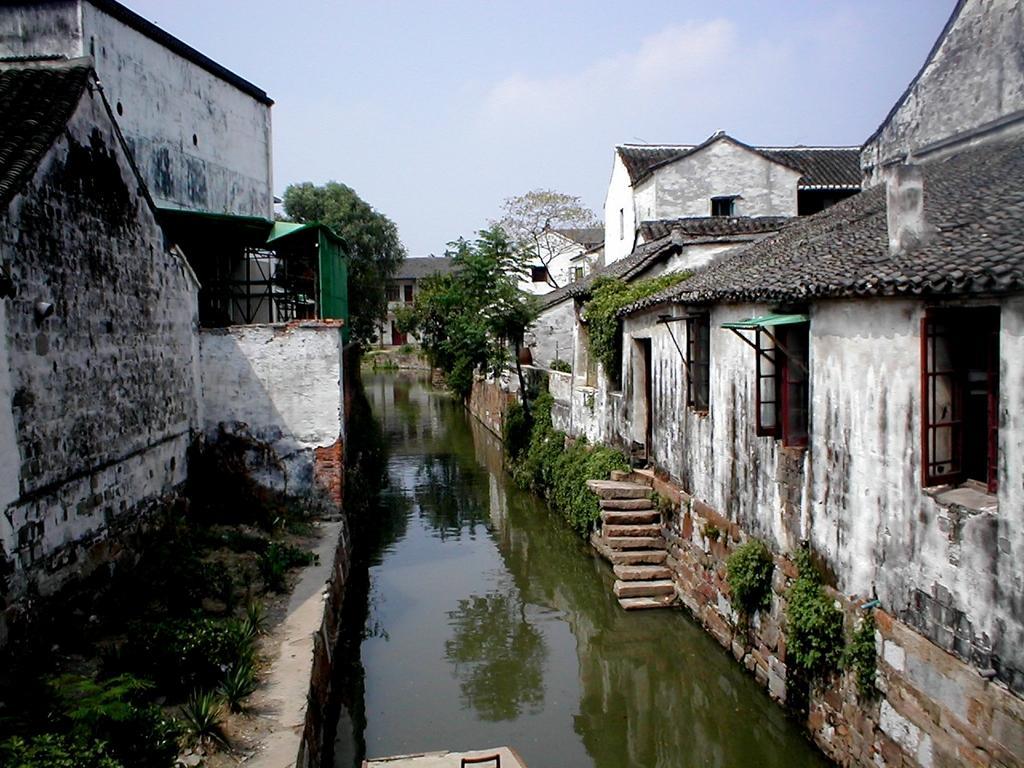Please provide a concise description of this image. This is an outside view. In the middle of the image there is a lake. On both sides of the lake there are many houses and trees. At the top of the image I can see the sky. 